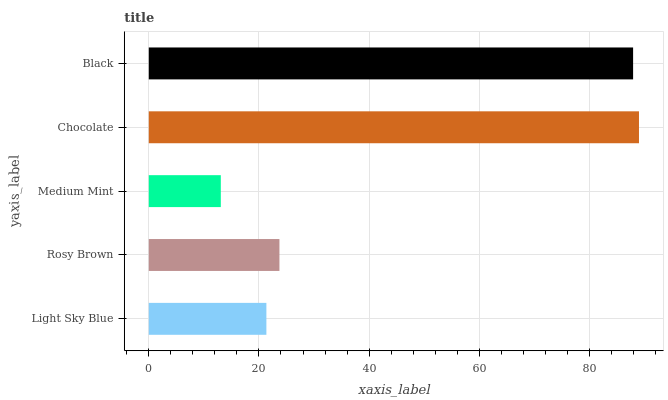Is Medium Mint the minimum?
Answer yes or no. Yes. Is Chocolate the maximum?
Answer yes or no. Yes. Is Rosy Brown the minimum?
Answer yes or no. No. Is Rosy Brown the maximum?
Answer yes or no. No. Is Rosy Brown greater than Light Sky Blue?
Answer yes or no. Yes. Is Light Sky Blue less than Rosy Brown?
Answer yes or no. Yes. Is Light Sky Blue greater than Rosy Brown?
Answer yes or no. No. Is Rosy Brown less than Light Sky Blue?
Answer yes or no. No. Is Rosy Brown the high median?
Answer yes or no. Yes. Is Rosy Brown the low median?
Answer yes or no. Yes. Is Black the high median?
Answer yes or no. No. Is Light Sky Blue the low median?
Answer yes or no. No. 